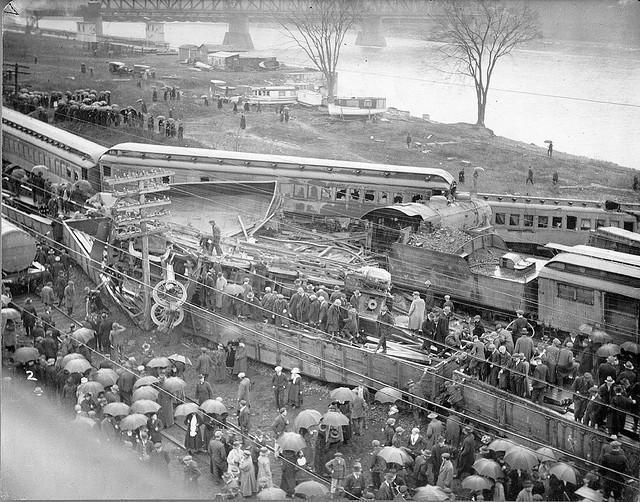How many trains can be seen?
Give a very brief answer. 3. 